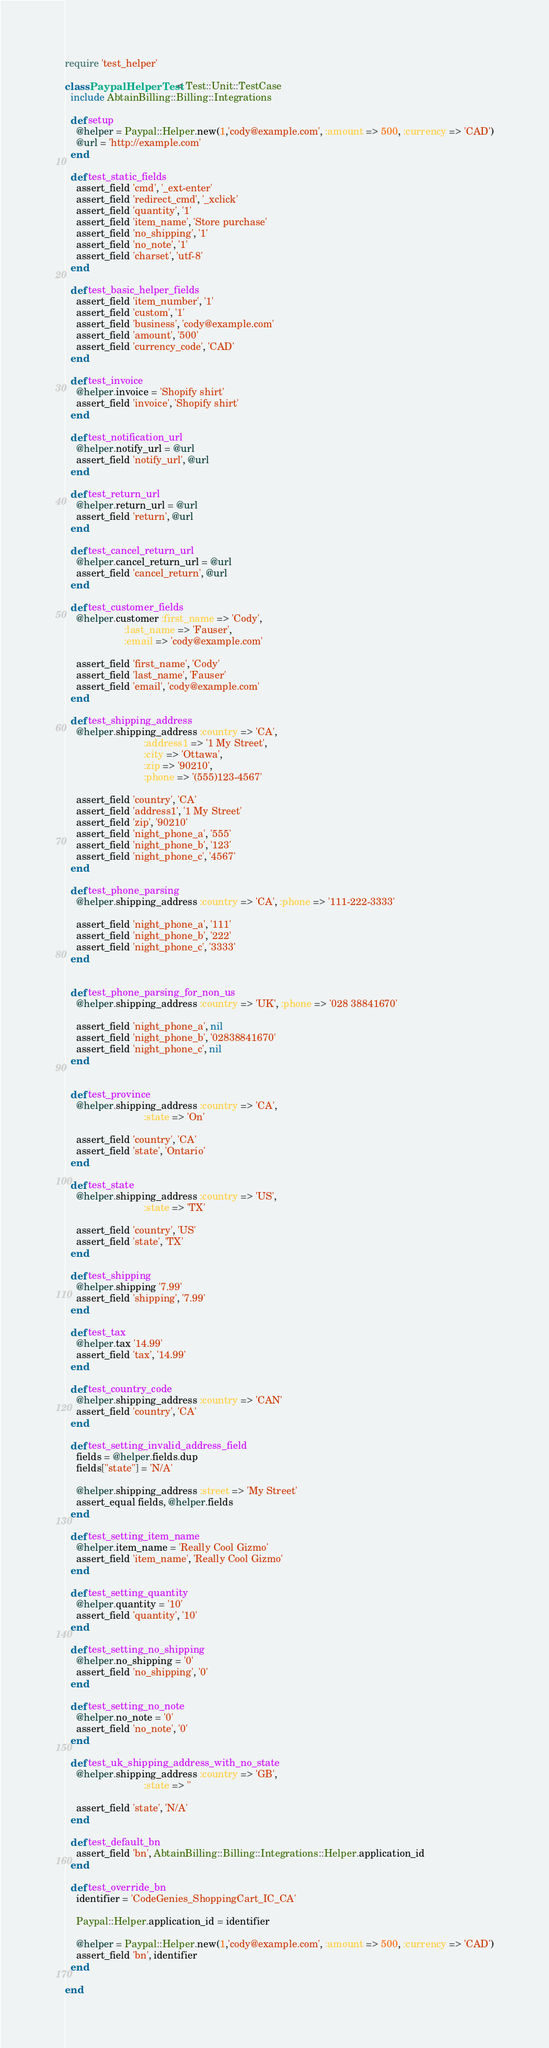<code> <loc_0><loc_0><loc_500><loc_500><_Ruby_>require 'test_helper'

class PaypalHelperTest < Test::Unit::TestCase
  include AbtainBilling::Billing::Integrations
  
  def setup
    @helper = Paypal::Helper.new(1,'cody@example.com', :amount => 500, :currency => 'CAD')
    @url = 'http://example.com'
  end
  
  def test_static_fields
    assert_field 'cmd', '_ext-enter'
    assert_field 'redirect_cmd', '_xclick'
    assert_field 'quantity', '1'
    assert_field 'item_name', 'Store purchase'
    assert_field 'no_shipping', '1'
    assert_field 'no_note', '1'
    assert_field 'charset', 'utf-8'
  end

  def test_basic_helper_fields
    assert_field 'item_number', '1'
    assert_field 'custom', '1'
    assert_field 'business', 'cody@example.com'
    assert_field 'amount', '500'
    assert_field 'currency_code', 'CAD'
  end

  def test_invoice
    @helper.invoice = 'Shopify shirt'
    assert_field 'invoice', 'Shopify shirt'
  end

  def test_notification_url
    @helper.notify_url = @url
    assert_field 'notify_url', @url
  end

  def test_return_url
    @helper.return_url = @url
    assert_field 'return', @url
  end
  
  def test_cancel_return_url
    @helper.cancel_return_url = @url
    assert_field 'cancel_return', @url
  end
 
  def test_customer_fields 
    @helper.customer :first_name => 'Cody', 
                     :last_name => 'Fauser',
                     :email => 'cody@example.com'

    assert_field 'first_name', 'Cody'
    assert_field 'last_name', 'Fauser'
    assert_field 'email', 'cody@example.com'
  end

  def test_shipping_address
    @helper.shipping_address :country => 'CA',
                            :address1 => '1 My Street',
                            :city => 'Ottawa',
                            :zip => '90210',
                            :phone => '(555)123-4567'

    assert_field 'country', 'CA'
    assert_field 'address1', '1 My Street'
    assert_field 'zip', '90210' 
    assert_field 'night_phone_a', '555'
    assert_field 'night_phone_b', '123'
    assert_field 'night_phone_c', '4567'
  end

  def test_phone_parsing
    @helper.shipping_address :country => 'CA', :phone => '111-222-3333'

    assert_field 'night_phone_a', '111'
    assert_field 'night_phone_b', '222'
    assert_field 'night_phone_c', '3333'
  end


  def test_phone_parsing_for_non_us
    @helper.shipping_address :country => 'UK', :phone => '028 38841670'

    assert_field 'night_phone_a', nil
    assert_field 'night_phone_b', '02838841670'
    assert_field 'night_phone_c', nil
  end
  
  
  def test_province
    @helper.shipping_address :country => 'CA',
                            :state => 'On'

    assert_field 'country', 'CA'
    assert_field 'state', 'Ontario'
  end

  def test_state
    @helper.shipping_address :country => 'US',
                            :state => 'TX'

    assert_field 'country', 'US'
    assert_field 'state', 'TX'
  end
  
  def test_shipping
    @helper.shipping '7.99'
    assert_field 'shipping', '7.99'
  end

  def test_tax
    @helper.tax '14.99'
    assert_field 'tax', '14.99'
  end

  def test_country_code
    @helper.shipping_address :country => 'CAN'
    assert_field 'country', 'CA'
  end

  def test_setting_invalid_address_field
    fields = @helper.fields.dup
    fields["state"] = 'N/A'
    
    @helper.shipping_address :street => 'My Street'
    assert_equal fields, @helper.fields
  end
  
  def test_setting_item_name
    @helper.item_name = 'Really Cool Gizmo'
    assert_field 'item_name', 'Really Cool Gizmo'
  end

  def test_setting_quantity
    @helper.quantity = '10'
    assert_field 'quantity', '10'
  end
  
  def test_setting_no_shipping
    @helper.no_shipping = '0'
    assert_field 'no_shipping', '0'
  end
  
  def test_setting_no_note
    @helper.no_note = '0'
    assert_field 'no_note', '0'
  end
  
  def test_uk_shipping_address_with_no_state
    @helper.shipping_address :country => 'GB',
                            :state => ''

    assert_field 'state', 'N/A'
  end
  
  def test_default_bn
    assert_field 'bn', AbtainBilling::Billing::Integrations::Helper.application_id 
  end
  
  def test_override_bn
    identifier = 'CodeGenies_ShoppingCart_IC_CA'
    
    Paypal::Helper.application_id = identifier
    
    @helper = Paypal::Helper.new(1,'cody@example.com', :amount => 500, :currency => 'CAD')
    assert_field 'bn', identifier 
  end
  
end
</code> 